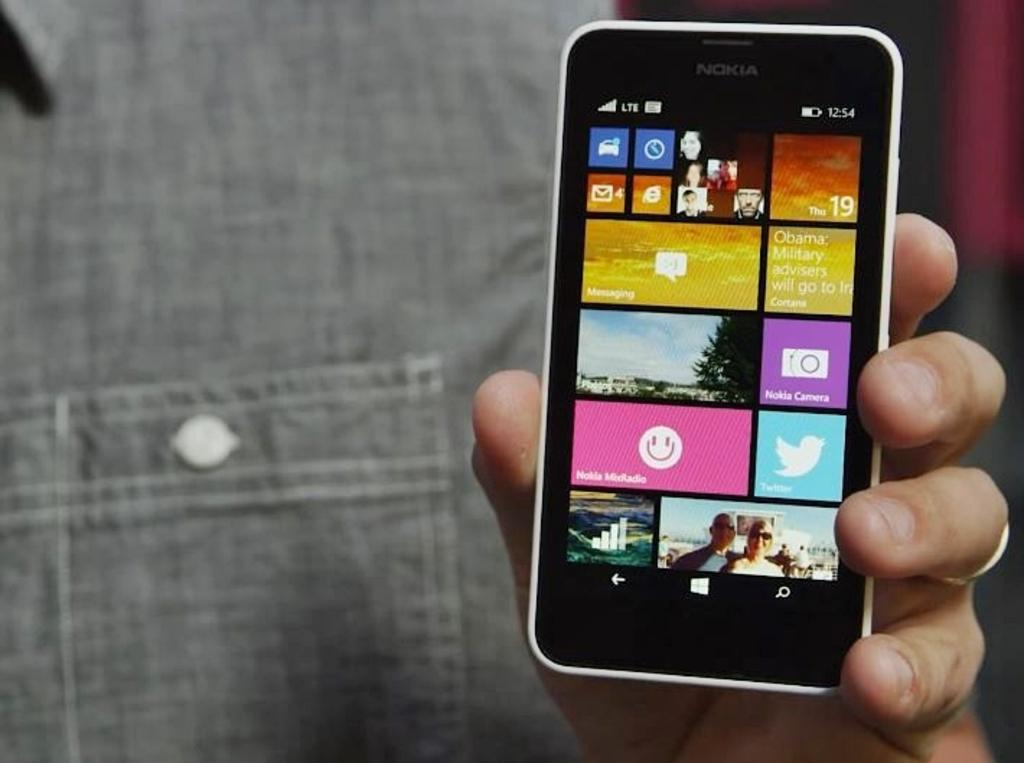<image>
Provide a brief description of the given image. A Nokia smart phone that shows a blurb about Obama military advisers. 